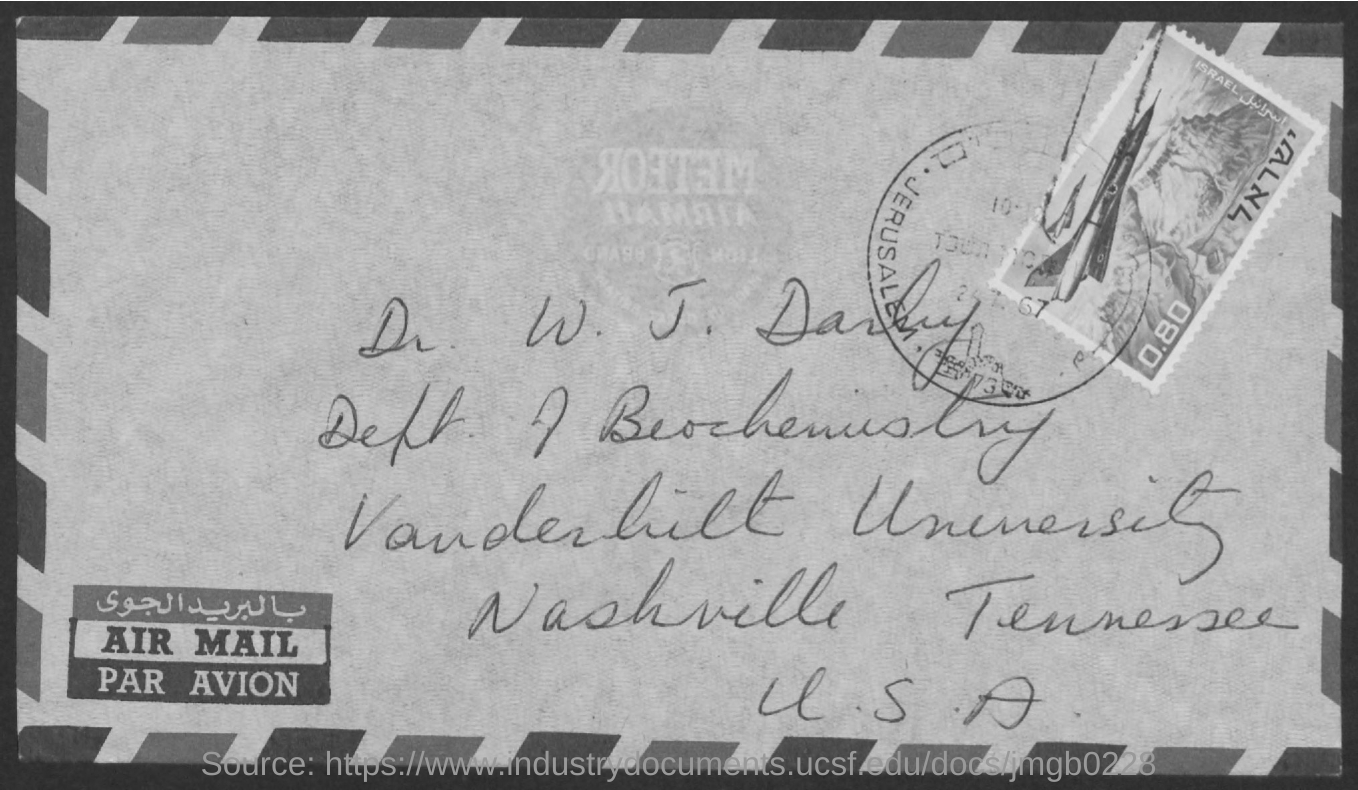What is the name of the person given in the address?
Provide a succinct answer. Dr. W. J. Darby. 